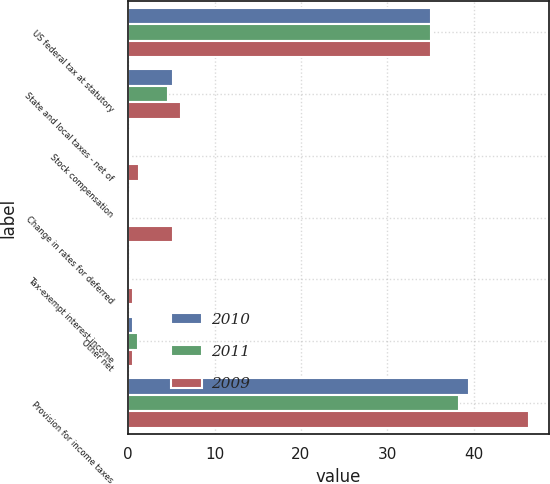Convert chart to OTSL. <chart><loc_0><loc_0><loc_500><loc_500><stacked_bar_chart><ecel><fcel>US federal tax at statutory<fcel>State and local taxes - net of<fcel>Stock compensation<fcel>Change in rates for deferred<fcel>Tax-exempt interest income<fcel>Other net<fcel>Provision for income taxes<nl><fcel>2010<fcel>35<fcel>5.2<fcel>0.1<fcel>0.2<fcel>0<fcel>0.5<fcel>39.4<nl><fcel>2011<fcel>35<fcel>4.6<fcel>0.1<fcel>0.1<fcel>0.1<fcel>1.1<fcel>38.3<nl><fcel>2009<fcel>35<fcel>6.1<fcel>1.2<fcel>5.2<fcel>0.6<fcel>0.5<fcel>46.4<nl></chart> 